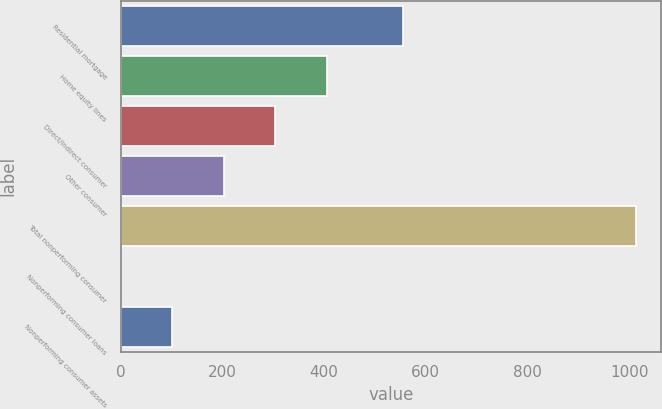Convert chart. <chart><loc_0><loc_0><loc_500><loc_500><bar_chart><fcel>Residential mortgage<fcel>Home equity lines<fcel>Direct/Indirect consumer<fcel>Other consumer<fcel>Total nonperforming consumer<fcel>Nonperforming consumer loans<fcel>Nonperforming consumer assets<nl><fcel>556<fcel>405.45<fcel>304.19<fcel>202.93<fcel>1013<fcel>0.41<fcel>101.67<nl></chart> 